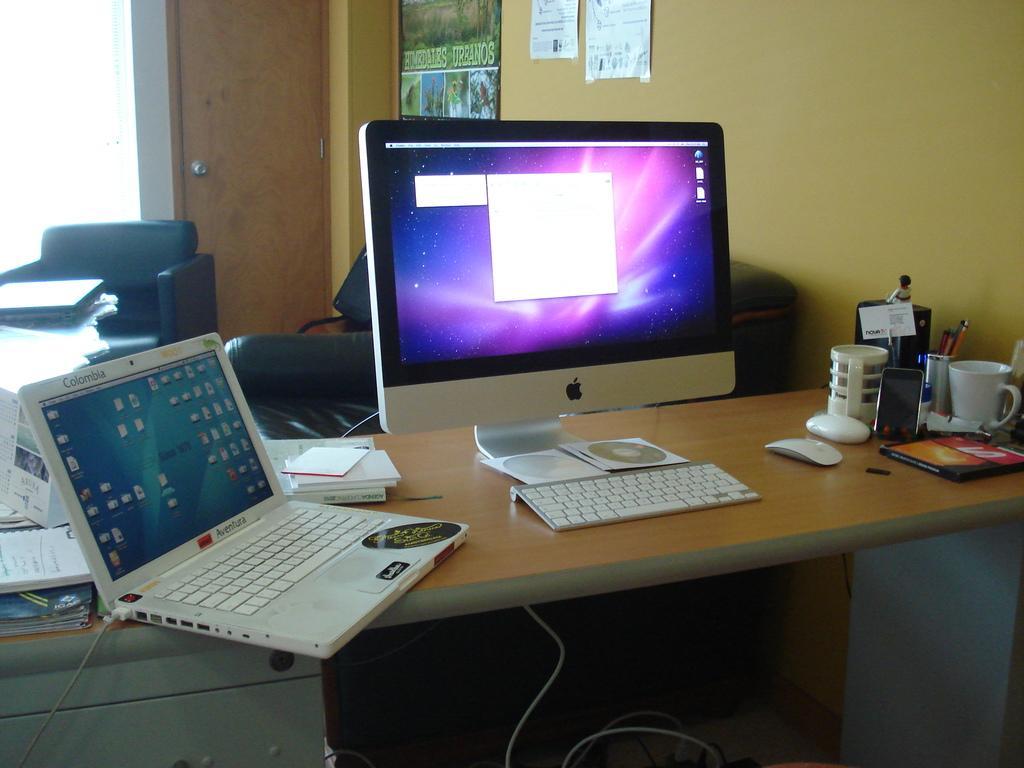Could you give a brief overview of what you see in this image? An indoor picture. On a table there is a monitor, keyboard and mouse. On wall there are posters. This is door. This is couch. A laptop is on a table. Beside this laptop there are books. On this table there are also cup, mobile and pen holder. 